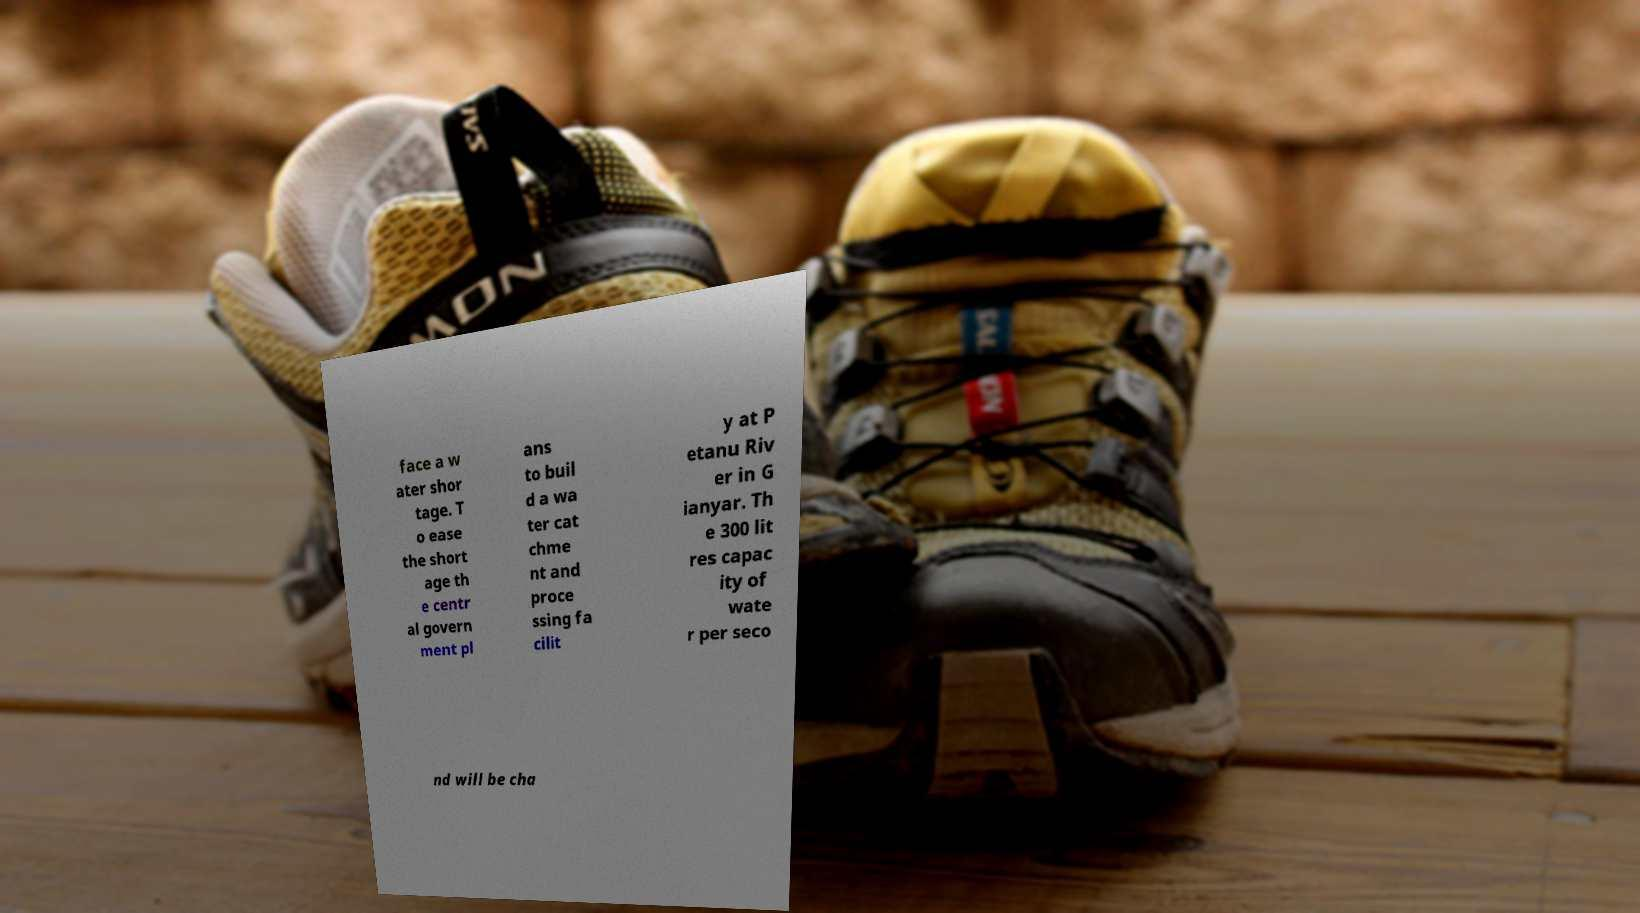Please read and relay the text visible in this image. What does it say? face a w ater shor tage. T o ease the short age th e centr al govern ment pl ans to buil d a wa ter cat chme nt and proce ssing fa cilit y at P etanu Riv er in G ianyar. Th e 300 lit res capac ity of wate r per seco nd will be cha 